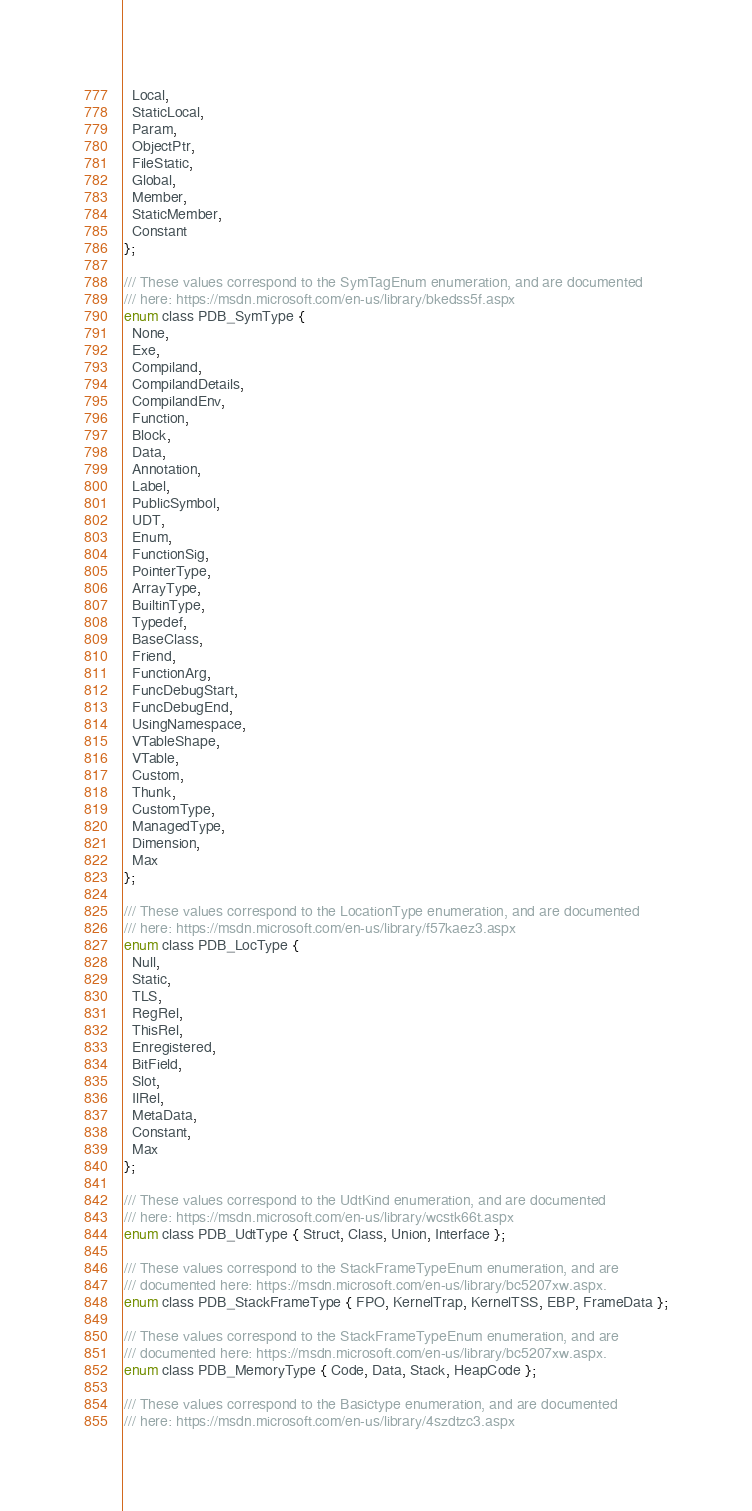<code> <loc_0><loc_0><loc_500><loc_500><_C_>  Local,
  StaticLocal,
  Param,
  ObjectPtr,
  FileStatic,
  Global,
  Member,
  StaticMember,
  Constant
};

/// These values correspond to the SymTagEnum enumeration, and are documented
/// here: https://msdn.microsoft.com/en-us/library/bkedss5f.aspx
enum class PDB_SymType {
  None,
  Exe,
  Compiland,
  CompilandDetails,
  CompilandEnv,
  Function,
  Block,
  Data,
  Annotation,
  Label,
  PublicSymbol,
  UDT,
  Enum,
  FunctionSig,
  PointerType,
  ArrayType,
  BuiltinType,
  Typedef,
  BaseClass,
  Friend,
  FunctionArg,
  FuncDebugStart,
  FuncDebugEnd,
  UsingNamespace,
  VTableShape,
  VTable,
  Custom,
  Thunk,
  CustomType,
  ManagedType,
  Dimension,
  Max
};

/// These values correspond to the LocationType enumeration, and are documented
/// here: https://msdn.microsoft.com/en-us/library/f57kaez3.aspx
enum class PDB_LocType {
  Null,
  Static,
  TLS,
  RegRel,
  ThisRel,
  Enregistered,
  BitField,
  Slot,
  IlRel,
  MetaData,
  Constant,
  Max
};

/// These values correspond to the UdtKind enumeration, and are documented
/// here: https://msdn.microsoft.com/en-us/library/wcstk66t.aspx
enum class PDB_UdtType { Struct, Class, Union, Interface };

/// These values correspond to the StackFrameTypeEnum enumeration, and are
/// documented here: https://msdn.microsoft.com/en-us/library/bc5207xw.aspx.
enum class PDB_StackFrameType { FPO, KernelTrap, KernelTSS, EBP, FrameData };

/// These values correspond to the StackFrameTypeEnum enumeration, and are
/// documented here: https://msdn.microsoft.com/en-us/library/bc5207xw.aspx.
enum class PDB_MemoryType { Code, Data, Stack, HeapCode };

/// These values correspond to the Basictype enumeration, and are documented
/// here: https://msdn.microsoft.com/en-us/library/4szdtzc3.aspx</code> 